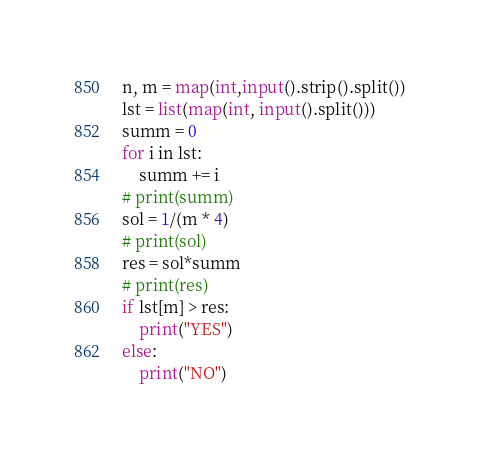Convert code to text. <code><loc_0><loc_0><loc_500><loc_500><_Python_>n, m = map(int,input().strip().split())
lst = list(map(int, input().split()))
summ = 0
for i in lst:
    summ += i
# print(summ)
sol = 1/(m * 4)
# print(sol)
res = sol*summ
# print(res)
if lst[m] > res:
    print("YES")
else:
    print("NO")</code> 